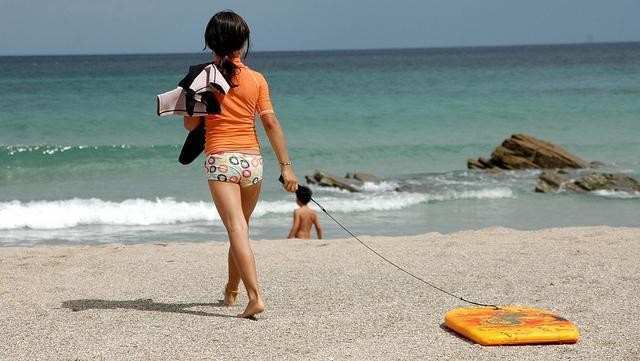How many bear arms are raised to the bears' ears?
Give a very brief answer. 0. 